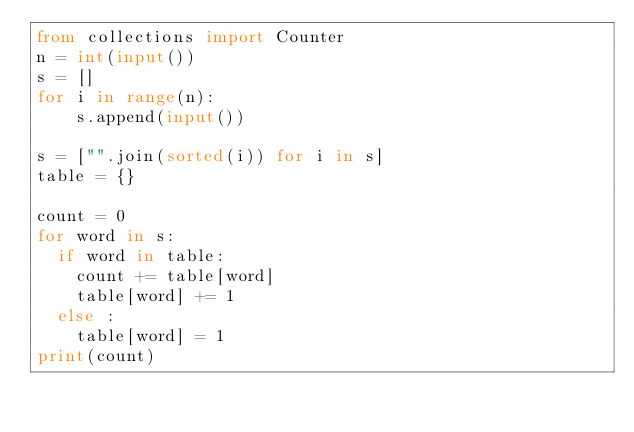<code> <loc_0><loc_0><loc_500><loc_500><_Python_>from collections import Counter
n = int(input())
s = []
for i in range(n):
  	s.append(input())

s = ["".join(sorted(i)) for i in s]
table = {}

count = 0
for word in s:
  if word in table:
    count += table[word]
    table[word] += 1
  else :
    table[word] = 1
print(count)</code> 